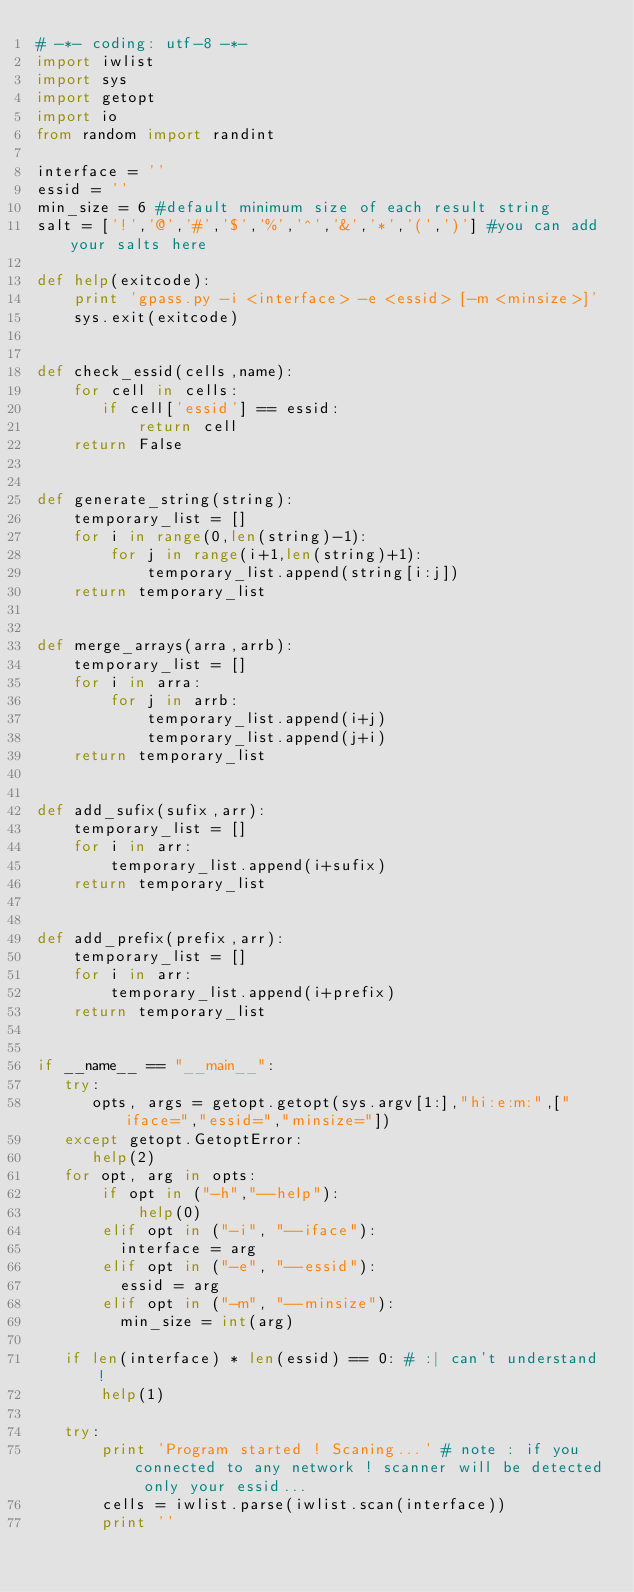<code> <loc_0><loc_0><loc_500><loc_500><_Python_># -*- coding: utf-8 -*-
import iwlist
import sys
import getopt
import io
from random import randint

interface = ''
essid = ''
min_size = 6 #default minimum size of each result string
salt = ['!','@','#','$','%','^','&','*','(',')'] #you can add your salts here

def help(exitcode):
    print 'gpass.py -i <interface> -e <essid> [-m <minsize>]'
    sys.exit(exitcode)
    
    
def check_essid(cells,name):    
    for cell in cells:
       if cell['essid'] == essid:
           return cell
    return False

    
def generate_string(string):
    temporary_list = []
    for i in range(0,len(string)-1):
        for j in range(i+1,len(string)+1):   
            temporary_list.append(string[i:j])
    return temporary_list


def merge_arrays(arra,arrb):
    temporary_list = []
    for i in arra:
        for j in arrb:
            temporary_list.append(i+j)
            temporary_list.append(j+i)
    return temporary_list


def add_sufix(sufix,arr):
    temporary_list = []
    for i in arr:
        temporary_list.append(i+sufix)
    return temporary_list

    
def add_prefix(prefix,arr):
    temporary_list = []
    for i in arr:
        temporary_list.append(i+prefix)
    return temporary_list


if __name__ == "__main__":
   try:
      opts, args = getopt.getopt(sys.argv[1:],"hi:e:m:",["iface=","essid=","minsize="])
   except getopt.GetoptError:
      help(2)
   for opt, arg in opts:
       if opt in ("-h","--help"):
           help(0)
       elif opt in ("-i", "--iface"):
         interface = arg
       elif opt in ("-e", "--essid"):
         essid = arg
       elif opt in ("-m", "--minsize"):
         min_size = int(arg)
   
   if len(interface) * len(essid) == 0: # :| can't understand !
       help(1)

   try:
       print 'Program started ! Scaning...' # note : if you connected to any network ! scanner will be detected only your essid...
       cells = iwlist.parse(iwlist.scan(interface))
       print ''</code> 